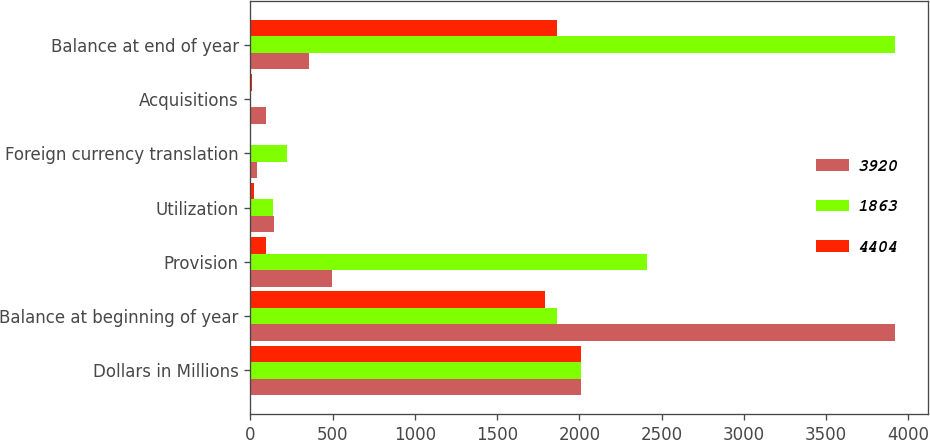Convert chart to OTSL. <chart><loc_0><loc_0><loc_500><loc_500><stacked_bar_chart><ecel><fcel>Dollars in Millions<fcel>Balance at beginning of year<fcel>Provision<fcel>Utilization<fcel>Foreign currency translation<fcel>Acquisitions<fcel>Balance at end of year<nl><fcel>3920<fcel>2012<fcel>3920<fcel>494<fcel>145<fcel>39<fcel>96<fcel>358<nl><fcel>1863<fcel>2011<fcel>1863<fcel>2410<fcel>135<fcel>222<fcel>4<fcel>3920<nl><fcel>4404<fcel>2010<fcel>1791<fcel>92<fcel>22<fcel>6<fcel>8<fcel>1863<nl></chart> 